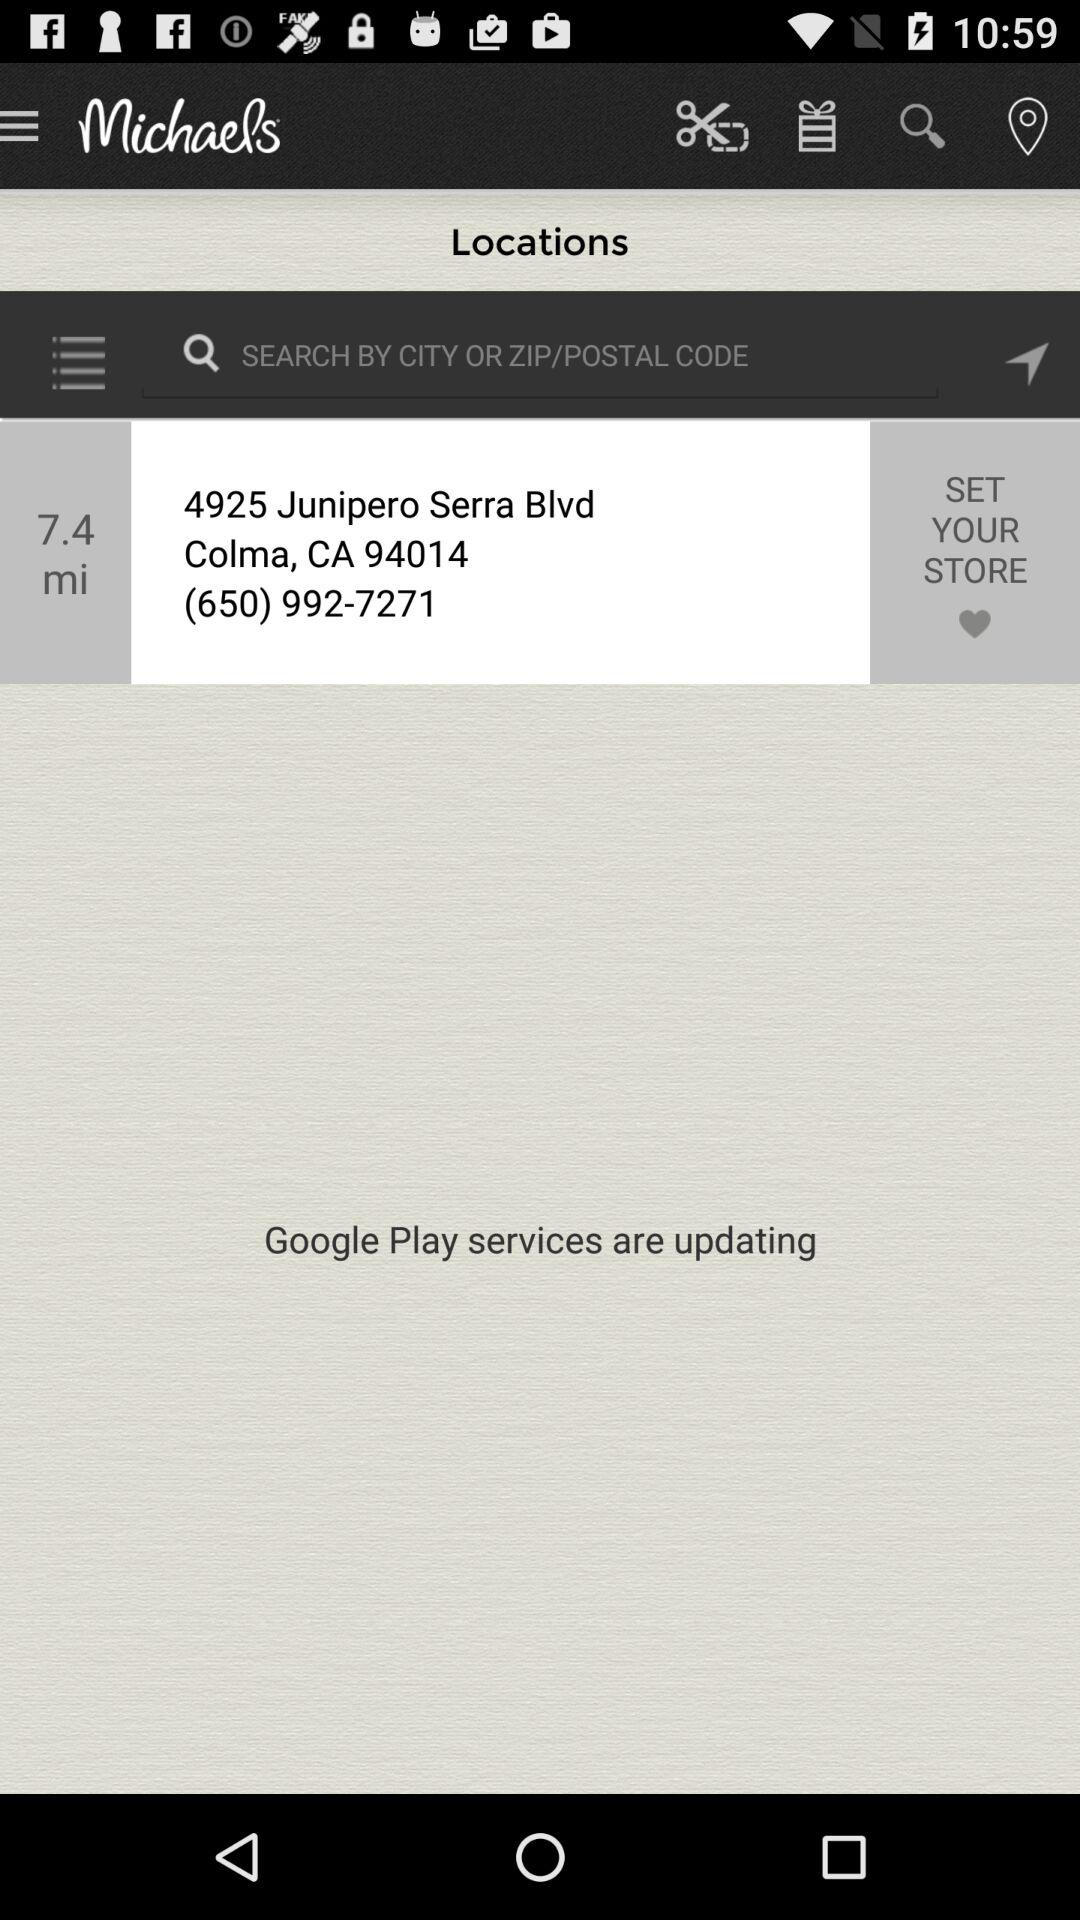What services are being updated? The service that is being updated is "Google Play". 